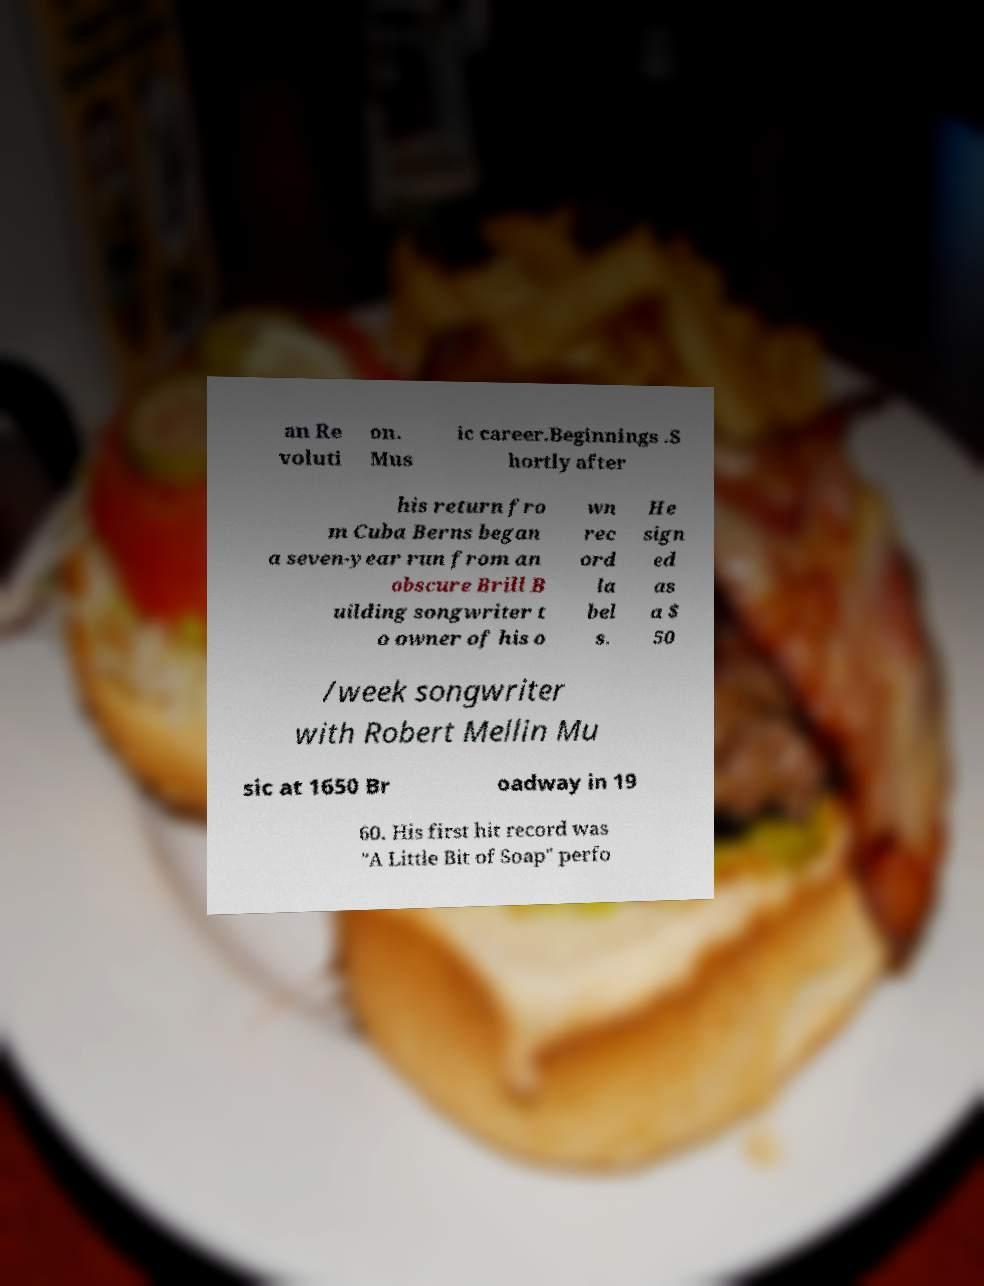Can you read and provide the text displayed in the image?This photo seems to have some interesting text. Can you extract and type it out for me? an Re voluti on. Mus ic career.Beginnings .S hortly after his return fro m Cuba Berns began a seven-year run from an obscure Brill B uilding songwriter t o owner of his o wn rec ord la bel s. He sign ed as a $ 50 /week songwriter with Robert Mellin Mu sic at 1650 Br oadway in 19 60. His first hit record was "A Little Bit of Soap" perfo 